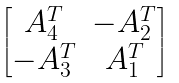<formula> <loc_0><loc_0><loc_500><loc_500>\begin{bmatrix} A _ { 4 } ^ { T } & - A _ { 2 } ^ { T } \\ - A _ { 3 } ^ { T } & A _ { 1 } ^ { T } \end{bmatrix}</formula> 